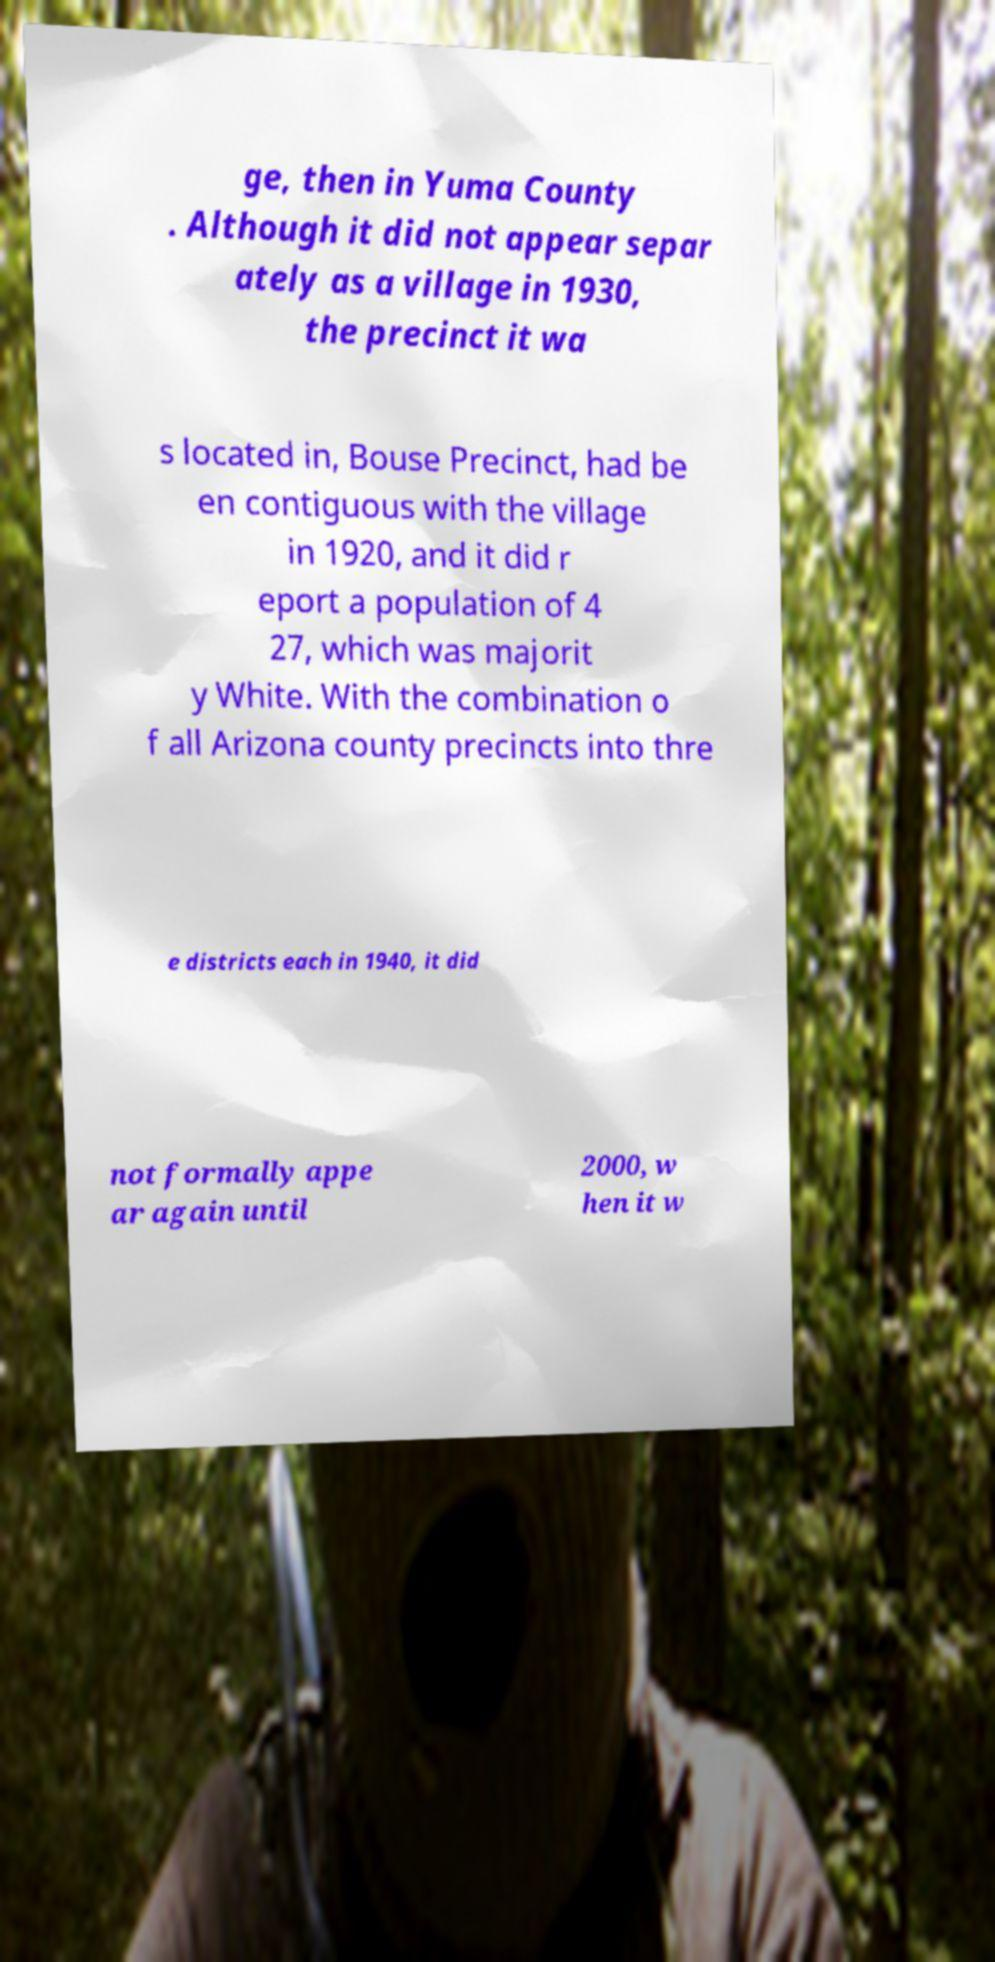Can you accurately transcribe the text from the provided image for me? ge, then in Yuma County . Although it did not appear separ ately as a village in 1930, the precinct it wa s located in, Bouse Precinct, had be en contiguous with the village in 1920, and it did r eport a population of 4 27, which was majorit y White. With the combination o f all Arizona county precincts into thre e districts each in 1940, it did not formally appe ar again until 2000, w hen it w 